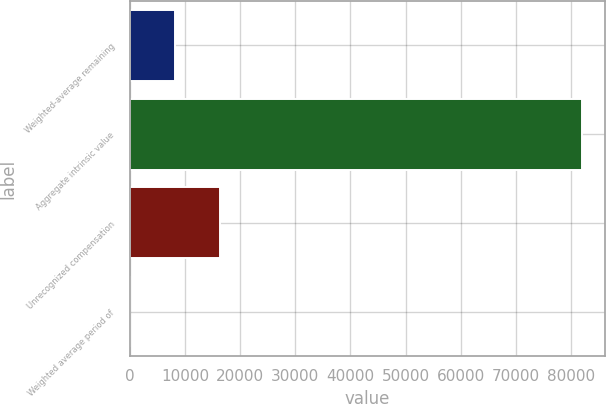Convert chart. <chart><loc_0><loc_0><loc_500><loc_500><bar_chart><fcel>Weighted-average remaining<fcel>Aggregate intrinsic value<fcel>Unrecognized compensation<fcel>Weighted average period of<nl><fcel>8202.09<fcel>82006<fcel>16402.5<fcel>1.65<nl></chart> 